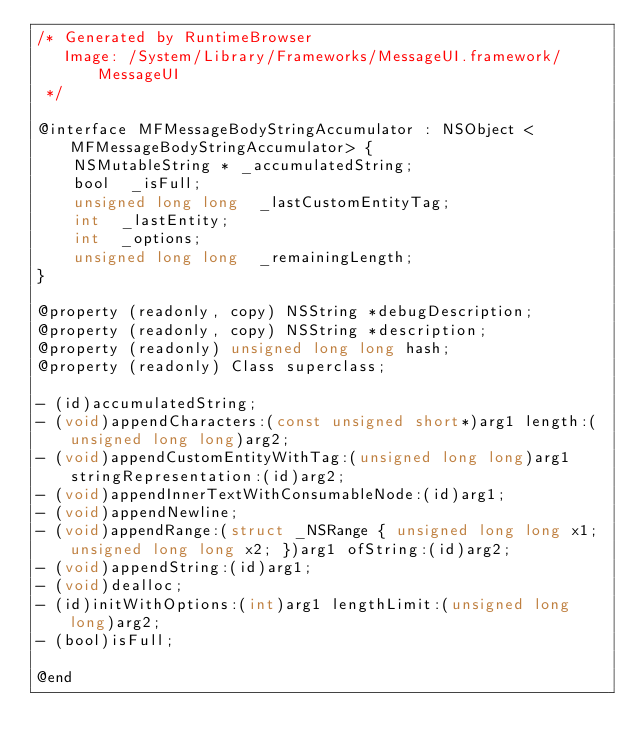Convert code to text. <code><loc_0><loc_0><loc_500><loc_500><_C_>/* Generated by RuntimeBrowser
   Image: /System/Library/Frameworks/MessageUI.framework/MessageUI
 */

@interface MFMessageBodyStringAccumulator : NSObject <MFMessageBodyStringAccumulator> {
    NSMutableString * _accumulatedString;
    bool  _isFull;
    unsigned long long  _lastCustomEntityTag;
    int  _lastEntity;
    int  _options;
    unsigned long long  _remainingLength;
}

@property (readonly, copy) NSString *debugDescription;
@property (readonly, copy) NSString *description;
@property (readonly) unsigned long long hash;
@property (readonly) Class superclass;

- (id)accumulatedString;
- (void)appendCharacters:(const unsigned short*)arg1 length:(unsigned long long)arg2;
- (void)appendCustomEntityWithTag:(unsigned long long)arg1 stringRepresentation:(id)arg2;
- (void)appendInnerTextWithConsumableNode:(id)arg1;
- (void)appendNewline;
- (void)appendRange:(struct _NSRange { unsigned long long x1; unsigned long long x2; })arg1 ofString:(id)arg2;
- (void)appendString:(id)arg1;
- (void)dealloc;
- (id)initWithOptions:(int)arg1 lengthLimit:(unsigned long long)arg2;
- (bool)isFull;

@end
</code> 